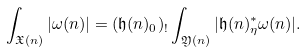Convert formula to latex. <formula><loc_0><loc_0><loc_500><loc_500>\int _ { \mathfrak X ( n ) } | \omega ( n ) | = ( \mathfrak h ( n ) _ { 0 } ) _ { ! } \int _ { \mathfrak Y ( n ) } | \mathfrak h ( n ) _ { \eta } ^ { * } \omega ( n ) | .</formula> 